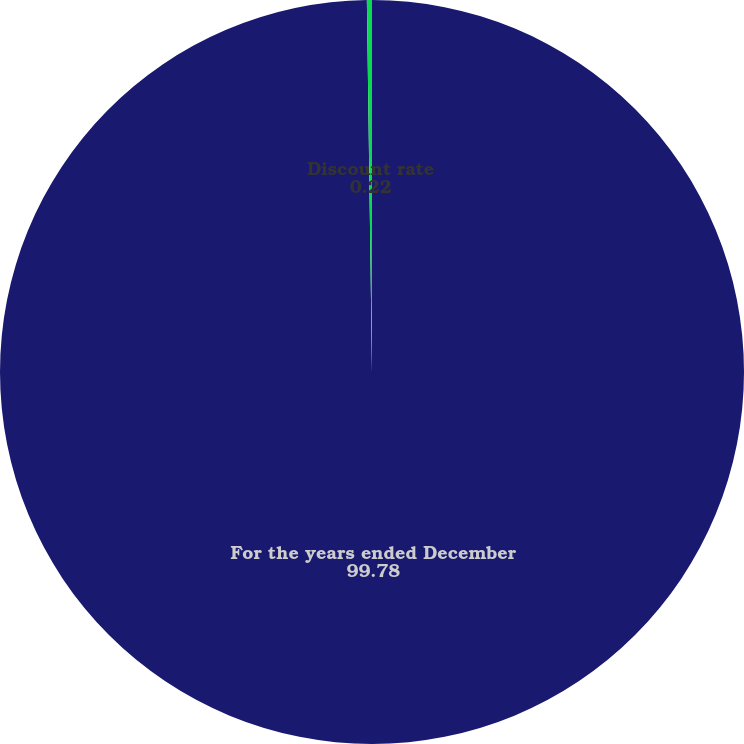<chart> <loc_0><loc_0><loc_500><loc_500><pie_chart><fcel>For the years ended December<fcel>Discount rate<nl><fcel>99.78%<fcel>0.22%<nl></chart> 